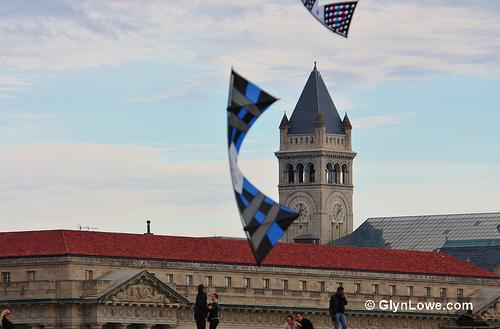What can you say about the roofing of the building in the image? The building has a red, triangle-shaped, tiled roof, with features like an aerial, a pole, and a metal pipe on top. In a single sentence, describe the main action taking place in this image. People are looking up at a multi-colored kite flying in the sky near a clock tower and a building with a red roof. What is the most prominent architectural feature in this image, and what color is it? The most prominent architectural feature is a red-roofed building with a large, pointed, gray clock tower. Can you count the number of people in this image and describe some of their activities? There are at least ten people in the image, some looking at the kite, one talking on the phone, and others posing for a photo or interacting with each other. Please provide a brief description of the primary object in the image. A large rectangular kite with blue and gray colors is flying in the sky, capturing the attention of people below. Provide a description of the sky in this image. The sky is partly cloudy, with a mixture of scattered clouds and blue sky, which sets a pleasant backdrop for the outdoor scene. How many flags are there in the picture, and what can you tell about their appearance? There is one visible flag, which is striped and has blue and black colors. Describe the interaction between people and the environment in this image. In the image, people are deeply engaged with their surroundings, watching a kite in the sky, looking at architecture, conversing with each other, and using the phone. What is the overall atmosphere of the image based on its elements? The image has a partly cloudy sky with people interacting below, enjoying a day outside while looking at a colorful kite and a clock tower with a red-roofed building nearby. Explain the image's sentiment or mood using descriptive words. The image evokes a lively, cheerful, and relaxed atmosphere, with people enjoying outdoor activities beneath a partly cloudy sky. What type of roof does the tower have? The tower has a gray roof. Mention the presence of any person using a device in the image. A man is using a phone at X:333, Y:283, Width:20, and Height:20. Describe the sentiment that the image portrays. The image portrays a positive and lively sentiment. What is the dominant color present in the image? The dominant color is a mix of blue and gray. Is the sky completely clear and blue? The image has several captions mentioning partly cloudy sky, suggesting it is not completely clear and blue. Describe the kite's appearance in the sky. The kite in the sky is rectangular, multi-colored, with dimensions X:199, Y:63, Width:94, and Height:94. Find the location of the "copyright" text in the image. The "copyright" text is at X:363, Y:289, Width:116, and Height:116. Identify potential anomalies in the image. There are no significant anomalies in the image. Provide a brief description of the image. A lively scene with various people interacting, a large building with a red roof, and a colorful kite in a partly cloudy sky. Is the roof of the tower shaped like a triangle? Yes, the roof is shaped like a triangle. Is there a green roof on any of the buildings? The image captions mention red and gray roofs, a red brick tile roof, and a tiled roof, but there is no mention of a green roof. How many clocks are on the tower? There is one clock on the tower. List three objects that are interacting in the picture. People looking up, people looking at the kite, and a striped flag hanging. Estimate the image's overall quality on a scale of 1 to 10. The image has a quality of 8 out of 10. Is there a person wearing a yellow shirt in the image? There are mentions of a person wearing a black shirt, a black jacket, and a grey jacket, but no mention of anyone wearing a yellow shirt. Can you find a flag hanging with a single solid color? The image captions mention a multi-colored flag, a blue and black flag and a stripped flag, but there are no captions referring to a flag with a single solid color. What is the weather like in the image? The weather appears to be partly cloudy. What is the material of the wall? The wall is brownish. Which objects in the image depict a sense of time? Clocks on the tower and an analog clock depict a sense of time. Point out the object with the highest Y co-ordinate? A large building with a red roof has the highest Y co-ordinate (Y=230). Is there a digital clock on the clock tower? The captions describe an analog clock, a clock on the tower, and a clock on the clock tower, but there is no mention of a digital clock in the image, suggesting that the clock is not digital. Which of the following objects is located at X:229, Y:84, Width:60, and Height:60? a) flag b) kite c) clock a) flag Are there any animals visible in the picture? The image captions describe various objects, people, and buildings, but there is no mention of animals, suggesting that they are not present in the image. What color is the flag on the roof? The flag is striped blue and black. What are the attributes of the person wearing a black shirt? The person is located at X:328 Y:281 with dimensions Width:20 and Height:20. 